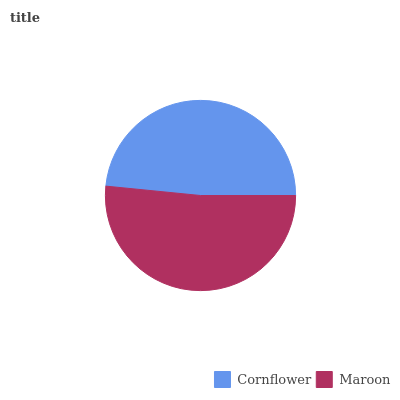Is Cornflower the minimum?
Answer yes or no. Yes. Is Maroon the maximum?
Answer yes or no. Yes. Is Maroon the minimum?
Answer yes or no. No. Is Maroon greater than Cornflower?
Answer yes or no. Yes. Is Cornflower less than Maroon?
Answer yes or no. Yes. Is Cornflower greater than Maroon?
Answer yes or no. No. Is Maroon less than Cornflower?
Answer yes or no. No. Is Maroon the high median?
Answer yes or no. Yes. Is Cornflower the low median?
Answer yes or no. Yes. Is Cornflower the high median?
Answer yes or no. No. Is Maroon the low median?
Answer yes or no. No. 